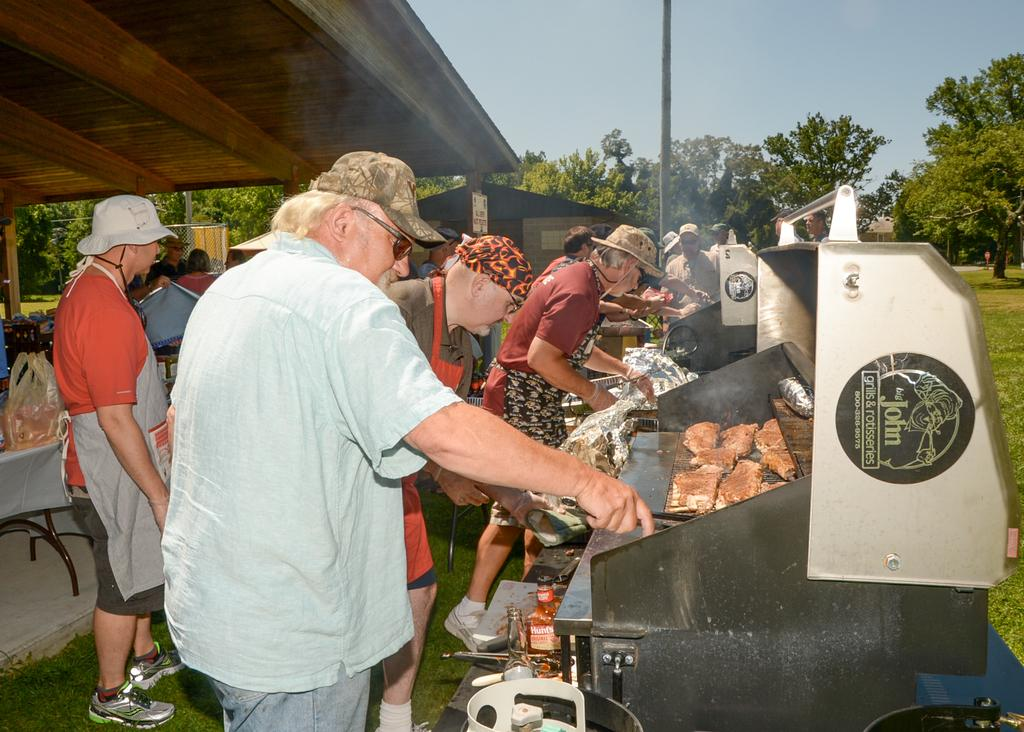How many people are in the image? There is a group of people in the image, but the exact number is not specified. What is the position of the people in the image? The people are standing on the ground in the image. What objects can be seen in the image besides the people? There is a table, a chair, a shelter, trees, a pole, bottles, and food items on a grill in the image. What is the background of the image? The sky is visible in the background of the image. What type of shoes are the people wearing in the image? There is no information about shoes in the image, as the focus is on the people standing on the ground and the surrounding objects and features. 